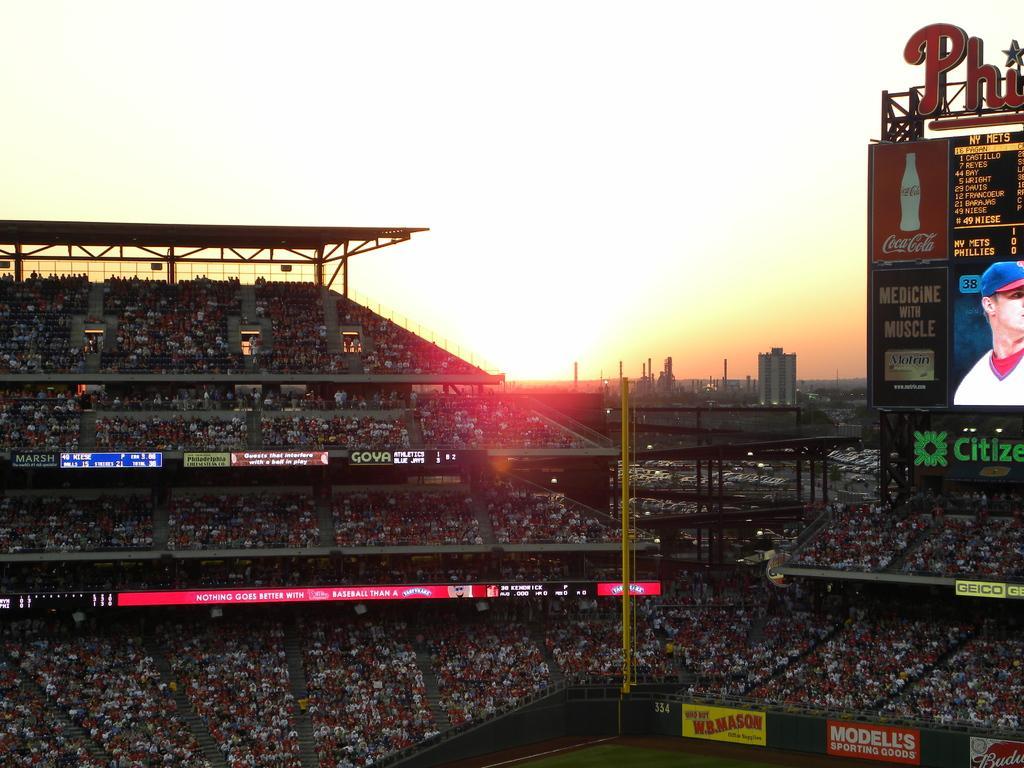In one or two sentences, can you explain what this image depicts? On the right side there is a screen and on the screen there is a person and there are some text written on the board. In the background there are buildings. 